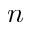Convert formula to latex. <formula><loc_0><loc_0><loc_500><loc_500>n</formula> 